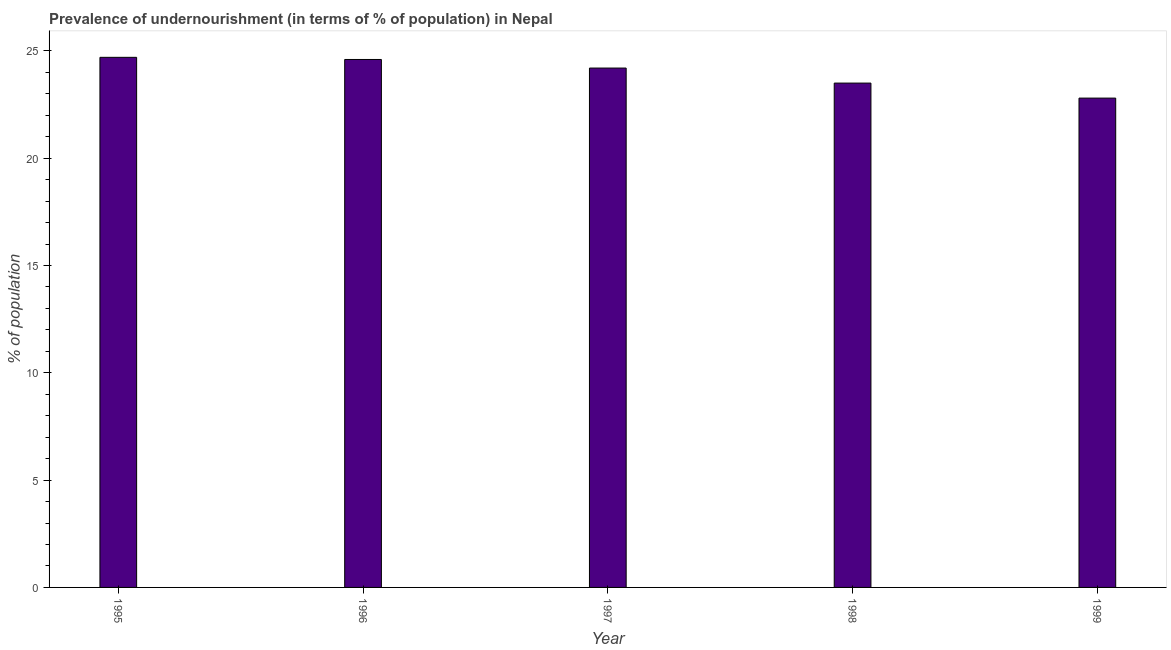Does the graph contain grids?
Your response must be concise. No. What is the title of the graph?
Provide a succinct answer. Prevalence of undernourishment (in terms of % of population) in Nepal. What is the label or title of the X-axis?
Offer a very short reply. Year. What is the label or title of the Y-axis?
Ensure brevity in your answer.  % of population. What is the percentage of undernourished population in 1995?
Your answer should be very brief. 24.7. Across all years, what is the maximum percentage of undernourished population?
Your answer should be very brief. 24.7. Across all years, what is the minimum percentage of undernourished population?
Your response must be concise. 22.8. In which year was the percentage of undernourished population minimum?
Your response must be concise. 1999. What is the sum of the percentage of undernourished population?
Ensure brevity in your answer.  119.8. What is the difference between the percentage of undernourished population in 1996 and 1997?
Your response must be concise. 0.4. What is the average percentage of undernourished population per year?
Provide a succinct answer. 23.96. What is the median percentage of undernourished population?
Your answer should be very brief. 24.2. Is the percentage of undernourished population in 1996 less than that in 1999?
Provide a short and direct response. No. What is the difference between the highest and the second highest percentage of undernourished population?
Your answer should be very brief. 0.1. How many bars are there?
Give a very brief answer. 5. How many years are there in the graph?
Give a very brief answer. 5. What is the % of population in 1995?
Offer a terse response. 24.7. What is the % of population in 1996?
Make the answer very short. 24.6. What is the % of population of 1997?
Make the answer very short. 24.2. What is the % of population in 1999?
Your answer should be very brief. 22.8. What is the difference between the % of population in 1995 and 1997?
Your answer should be very brief. 0.5. What is the difference between the % of population in 1996 and 1997?
Keep it short and to the point. 0.4. What is the difference between the % of population in 1996 and 1998?
Ensure brevity in your answer.  1.1. What is the difference between the % of population in 1996 and 1999?
Make the answer very short. 1.8. What is the difference between the % of population in 1997 and 1998?
Make the answer very short. 0.7. What is the difference between the % of population in 1997 and 1999?
Offer a terse response. 1.4. What is the difference between the % of population in 1998 and 1999?
Your answer should be compact. 0.7. What is the ratio of the % of population in 1995 to that in 1996?
Provide a short and direct response. 1. What is the ratio of the % of population in 1995 to that in 1997?
Provide a succinct answer. 1.02. What is the ratio of the % of population in 1995 to that in 1998?
Your answer should be compact. 1.05. What is the ratio of the % of population in 1995 to that in 1999?
Your answer should be compact. 1.08. What is the ratio of the % of population in 1996 to that in 1997?
Give a very brief answer. 1.02. What is the ratio of the % of population in 1996 to that in 1998?
Give a very brief answer. 1.05. What is the ratio of the % of population in 1996 to that in 1999?
Keep it short and to the point. 1.08. What is the ratio of the % of population in 1997 to that in 1998?
Your answer should be compact. 1.03. What is the ratio of the % of population in 1997 to that in 1999?
Make the answer very short. 1.06. What is the ratio of the % of population in 1998 to that in 1999?
Your answer should be very brief. 1.03. 